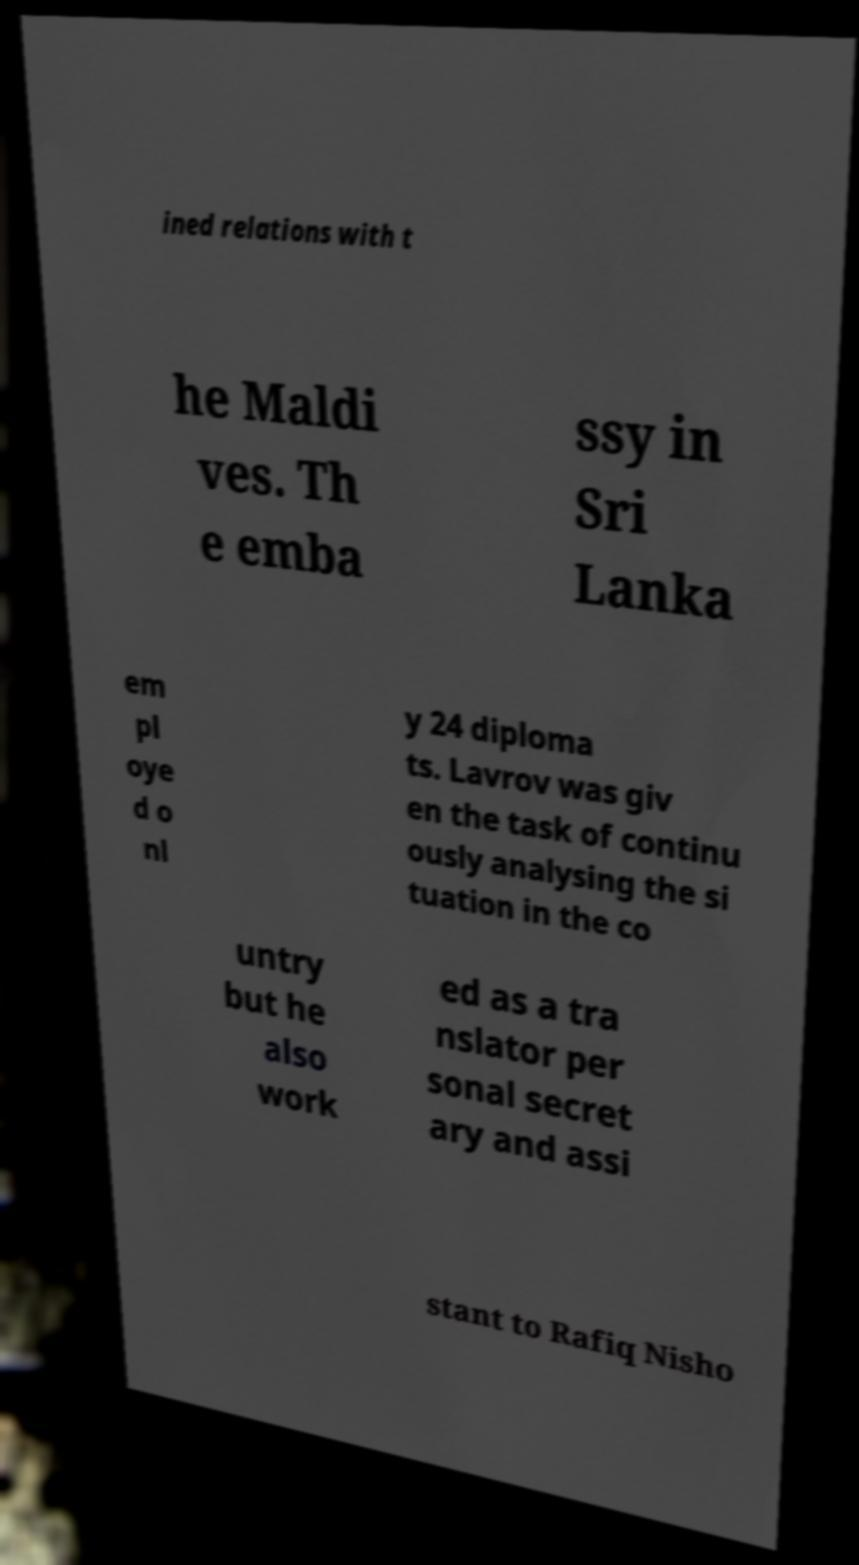Can you accurately transcribe the text from the provided image for me? ined relations with t he Maldi ves. Th e emba ssy in Sri Lanka em pl oye d o nl y 24 diploma ts. Lavrov was giv en the task of continu ously analysing the si tuation in the co untry but he also work ed as a tra nslator per sonal secret ary and assi stant to Rafiq Nisho 